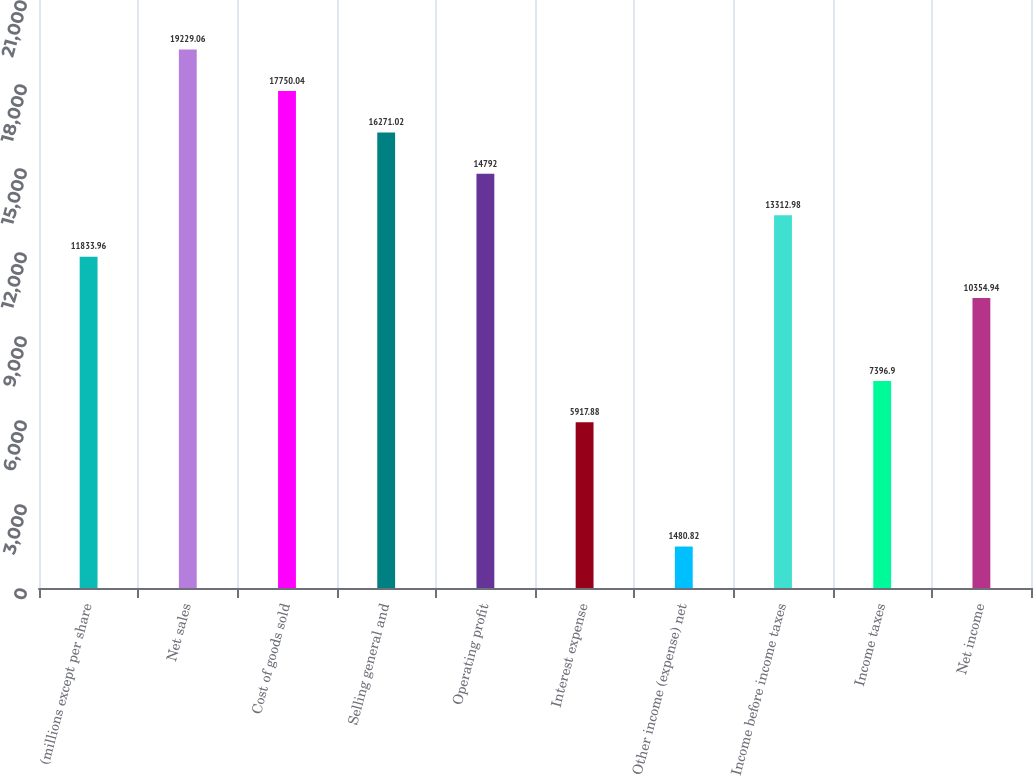Convert chart. <chart><loc_0><loc_0><loc_500><loc_500><bar_chart><fcel>(millions except per share<fcel>Net sales<fcel>Cost of goods sold<fcel>Selling general and<fcel>Operating profit<fcel>Interest expense<fcel>Other income (expense) net<fcel>Income before income taxes<fcel>Income taxes<fcel>Net income<nl><fcel>11834<fcel>19229.1<fcel>17750<fcel>16271<fcel>14792<fcel>5917.88<fcel>1480.82<fcel>13313<fcel>7396.9<fcel>10354.9<nl></chart> 